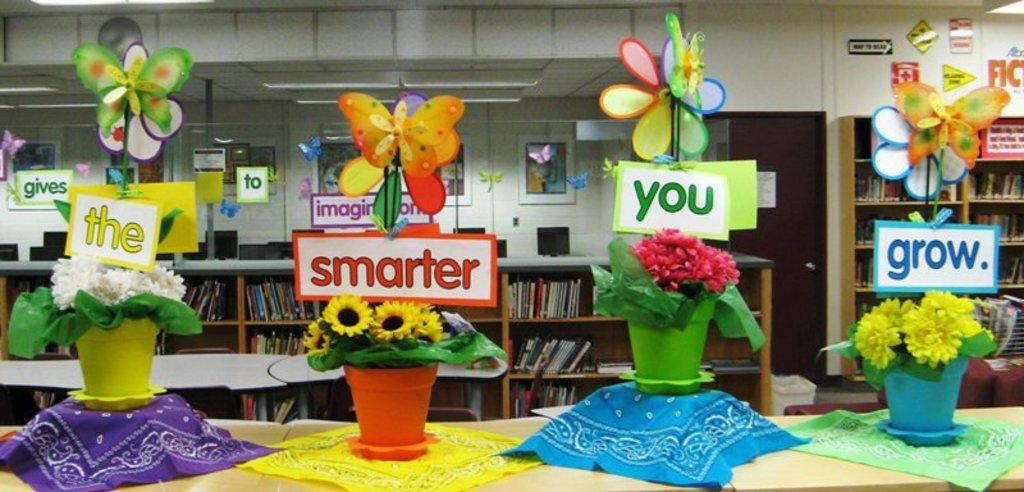What is located in the center of the image? There are flower pots in the center of the image. Where are the flower pots placed? The flower pots are placed on a table. What can be seen in the background of the image? There are bookshelves in the background of the image. What type of dinner is being served in the image? There is no dinner present in the image; it features flower pots on a table and bookshelves in the background. Can you see any deer in the image? There are no deer present in the image. 